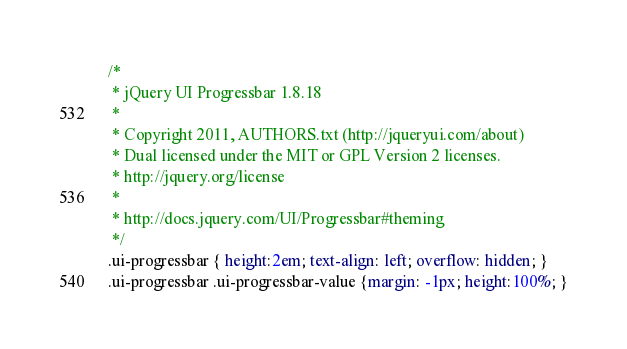<code> <loc_0><loc_0><loc_500><loc_500><_CSS_>/*
 * jQuery UI Progressbar 1.8.18
 *
 * Copyright 2011, AUTHORS.txt (http://jqueryui.com/about)
 * Dual licensed under the MIT or GPL Version 2 licenses.
 * http://jquery.org/license
 *
 * http://docs.jquery.com/UI/Progressbar#theming
 */
.ui-progressbar { height:2em; text-align: left; overflow: hidden; }
.ui-progressbar .ui-progressbar-value {margin: -1px; height:100%; }</code> 